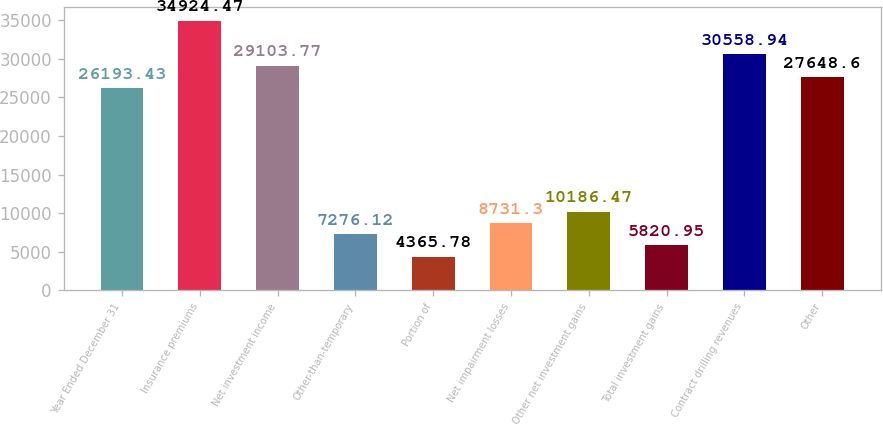<chart> <loc_0><loc_0><loc_500><loc_500><bar_chart><fcel>Year Ended December 31<fcel>Insurance premiums<fcel>Net investment income<fcel>Other-than-temporary<fcel>Portion of<fcel>Net impairment losses<fcel>Other net investment gains<fcel>Total investment gains<fcel>Contract drilling revenues<fcel>Other<nl><fcel>26193.4<fcel>34924.5<fcel>29103.8<fcel>7276.12<fcel>4365.78<fcel>8731.3<fcel>10186.5<fcel>5820.95<fcel>30558.9<fcel>27648.6<nl></chart> 